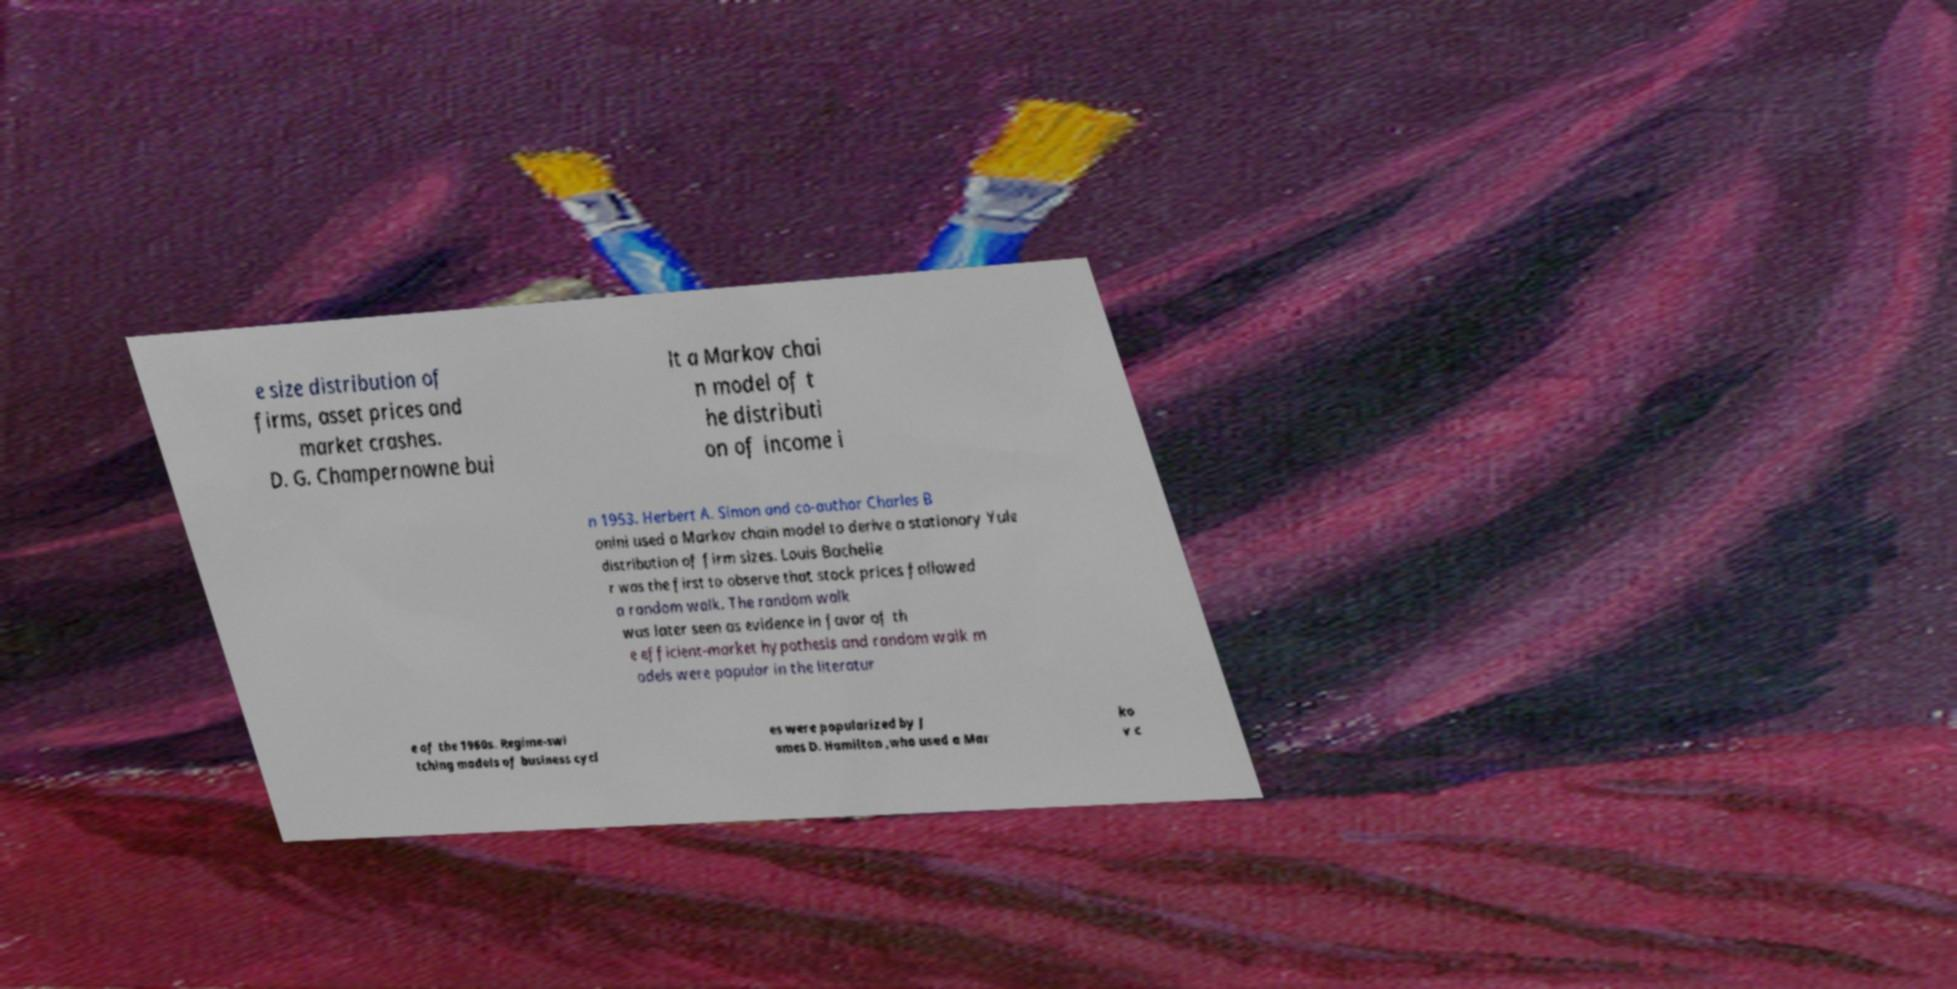Please identify and transcribe the text found in this image. e size distribution of firms, asset prices and market crashes. D. G. Champernowne bui lt a Markov chai n model of t he distributi on of income i n 1953. Herbert A. Simon and co-author Charles B onini used a Markov chain model to derive a stationary Yule distribution of firm sizes. Louis Bachelie r was the first to observe that stock prices followed a random walk. The random walk was later seen as evidence in favor of th e efficient-market hypothesis and random walk m odels were popular in the literatur e of the 1960s. Regime-swi tching models of business cycl es were popularized by J ames D. Hamilton ,who used a Mar ko v c 